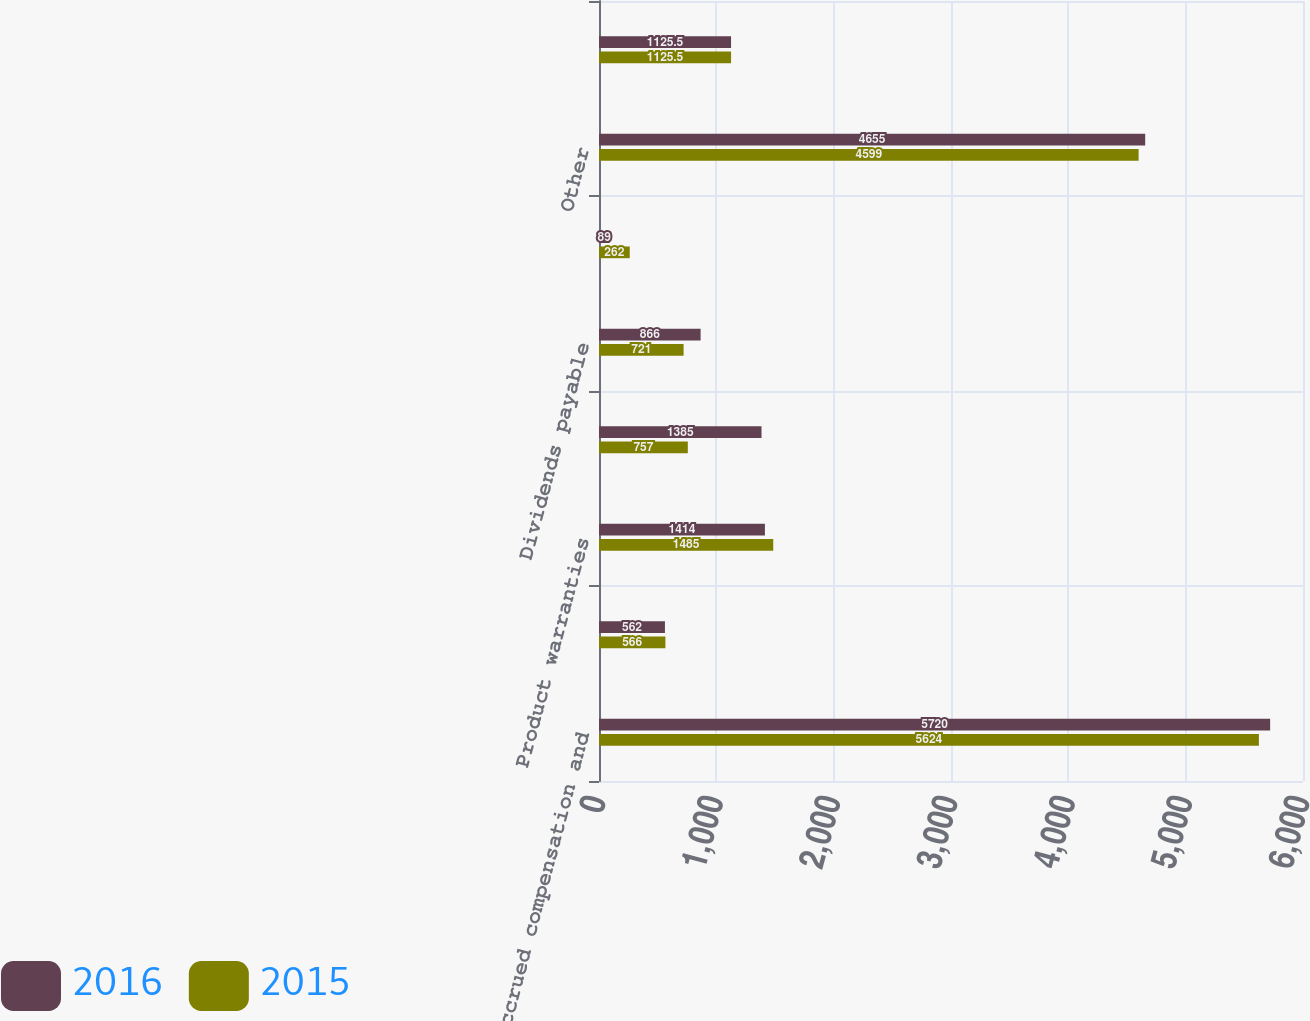Convert chart. <chart><loc_0><loc_0><loc_500><loc_500><stacked_bar_chart><ecel><fcel>Accrued compensation and<fcel>Environmental<fcel>Product warranties<fcel>Forward loss recognition<fcel>Dividends payable<fcel>Income Taxes Payable<fcel>Other<fcel>Total<nl><fcel>2016<fcel>5720<fcel>562<fcel>1414<fcel>1385<fcel>866<fcel>89<fcel>4655<fcel>1125.5<nl><fcel>2015<fcel>5624<fcel>566<fcel>1485<fcel>757<fcel>721<fcel>262<fcel>4599<fcel>1125.5<nl></chart> 